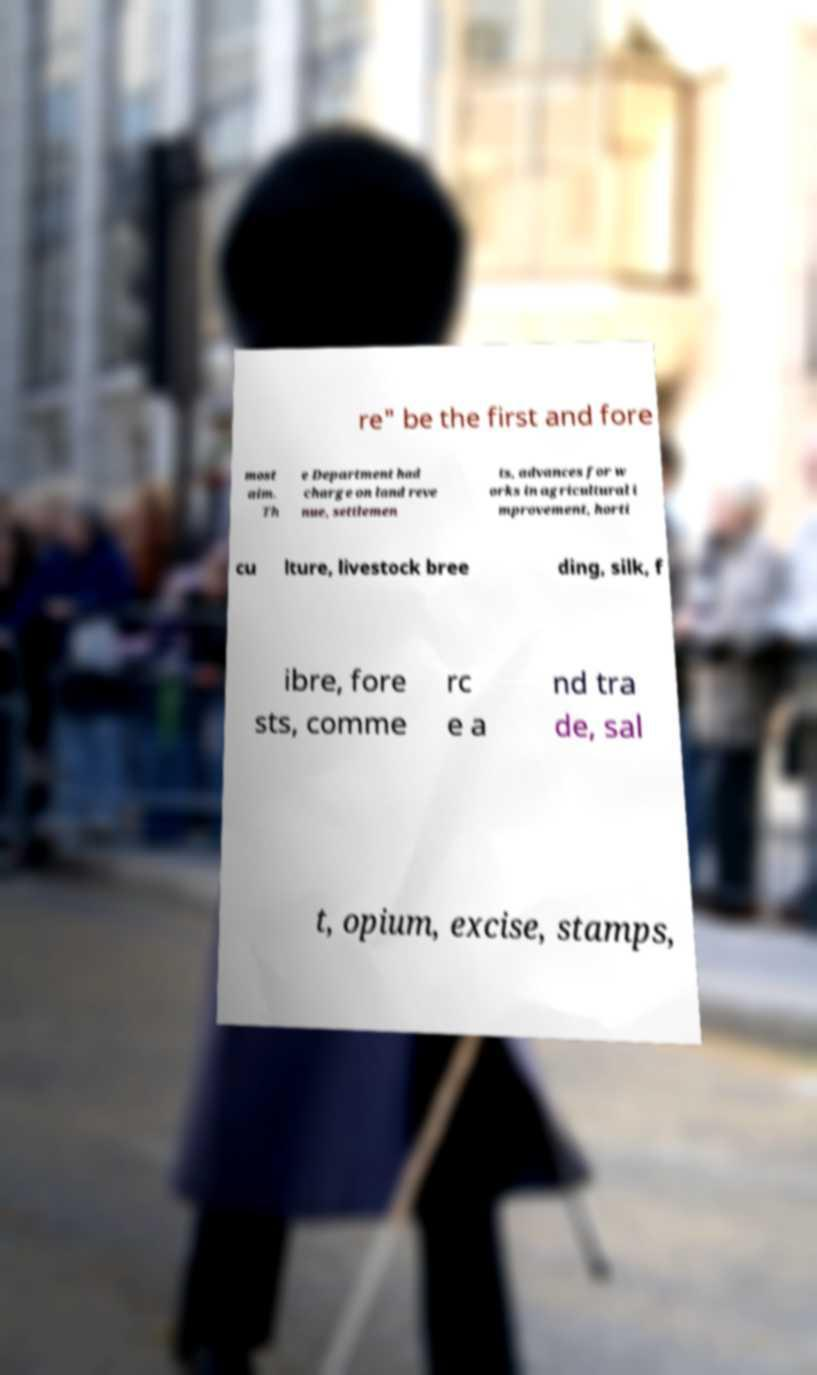Could you extract and type out the text from this image? re" be the first and fore most aim. Th e Department had charge on land reve nue, settlemen ts, advances for w orks in agricultural i mprovement, horti cu lture, livestock bree ding, silk, f ibre, fore sts, comme rc e a nd tra de, sal t, opium, excise, stamps, 